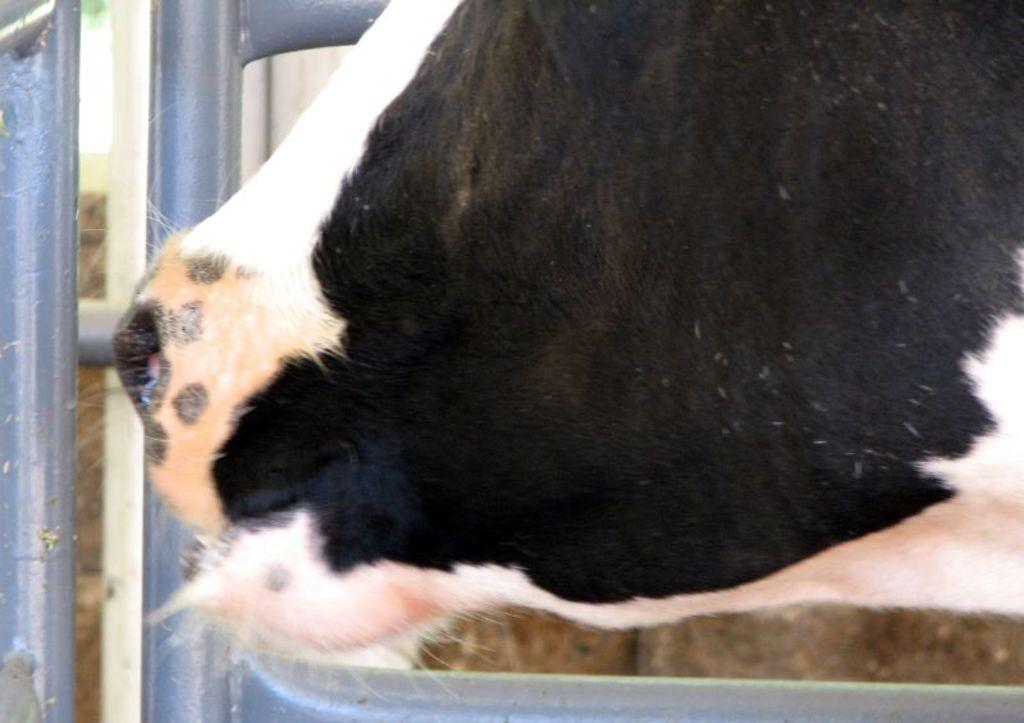What type of animal can be seen in the image? There is an animal in the image, but its specific type cannot be determined from the provided facts. What colors are present on the animal? The animal has black, white, and brown colors. Where is the animal located in relation to the railing? The animal is near the railing. What color is the wall visible in the background? The wall in the background is brown in color. What is the color of the sky in the image? The sky is white in color. How does the animal process information in the image? The provided facts do not give any information about the animal's cognitive abilities or how it processes information, so we cannot answer this question. Can you see the animal rubbing against the wall in the image? There is no mention of the animal rubbing against the wall in the provided facts, so we cannot answer this question. 